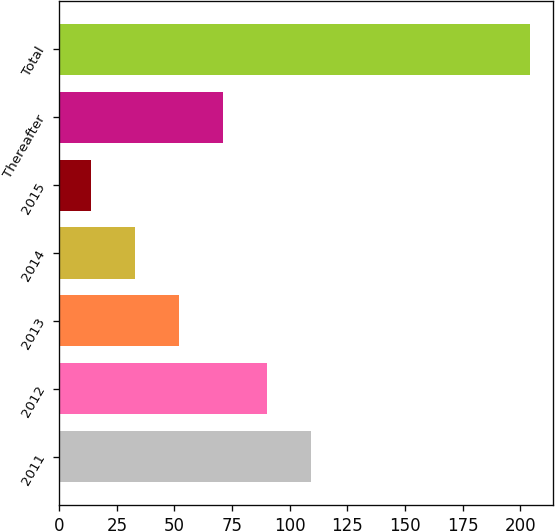<chart> <loc_0><loc_0><loc_500><loc_500><bar_chart><fcel>2011<fcel>2012<fcel>2013<fcel>2014<fcel>2015<fcel>Thereafter<fcel>Total<nl><fcel>109<fcel>90<fcel>52<fcel>33<fcel>14<fcel>71<fcel>204<nl></chart> 